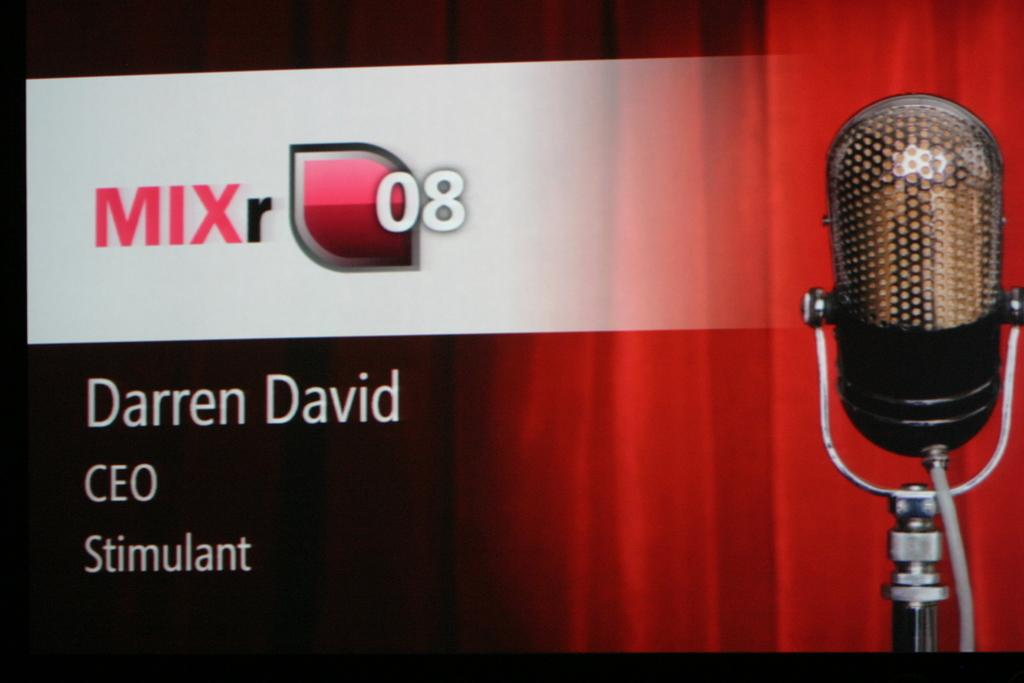What is featured in the picture? There is a poster in the picture. What can be found on the poster? There are words and numbers on the poster. What image is depicted on the poster? There is an image of a microphone (mike) on the poster. What type of animal can be seen swinging on a bridge in the image? There is no animal, swing, or bridge present in the image; it only features a poster with words, numbers, and a microphone image. 